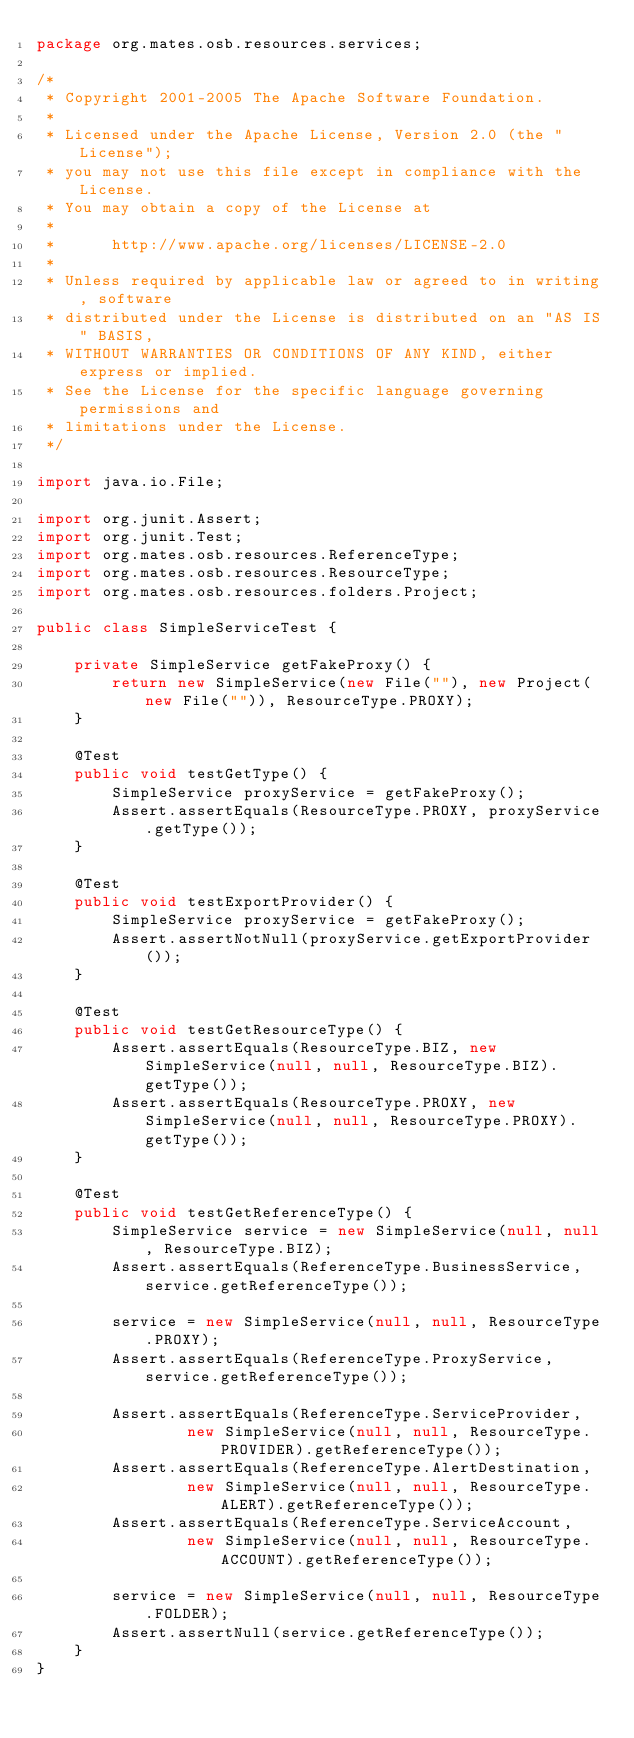Convert code to text. <code><loc_0><loc_0><loc_500><loc_500><_Java_>package org.mates.osb.resources.services;

/*
 * Copyright 2001-2005 The Apache Software Foundation.
 *
 * Licensed under the Apache License, Version 2.0 (the "License");
 * you may not use this file except in compliance with the License.
 * You may obtain a copy of the License at
 *
 *      http://www.apache.org/licenses/LICENSE-2.0
 *
 * Unless required by applicable law or agreed to in writing, software
 * distributed under the License is distributed on an "AS IS" BASIS,
 * WITHOUT WARRANTIES OR CONDITIONS OF ANY KIND, either express or implied.
 * See the License for the specific language governing permissions and
 * limitations under the License.
 */

import java.io.File;

import org.junit.Assert;
import org.junit.Test;
import org.mates.osb.resources.ReferenceType;
import org.mates.osb.resources.ResourceType;
import org.mates.osb.resources.folders.Project;

public class SimpleServiceTest {

	private SimpleService getFakeProxy() {
		return new SimpleService(new File(""), new Project(new File("")), ResourceType.PROXY);
	}

	@Test
	public void testGetType() {
		SimpleService proxyService = getFakeProxy();
		Assert.assertEquals(ResourceType.PROXY, proxyService.getType());
	}

	@Test
	public void testExportProvider() {
		SimpleService proxyService = getFakeProxy();
		Assert.assertNotNull(proxyService.getExportProvider());
	}
	
	@Test
	public void testGetResourceType() {
		Assert.assertEquals(ResourceType.BIZ, new SimpleService(null, null, ResourceType.BIZ).getType());
		Assert.assertEquals(ResourceType.PROXY, new SimpleService(null, null, ResourceType.PROXY).getType());
	}

	@Test
	public void testGetReferenceType() {
		SimpleService service = new SimpleService(null, null, ResourceType.BIZ);
		Assert.assertEquals(ReferenceType.BusinessService, service.getReferenceType());

		service = new SimpleService(null, null, ResourceType.PROXY);
		Assert.assertEquals(ReferenceType.ProxyService, service.getReferenceType());

		Assert.assertEquals(ReferenceType.ServiceProvider,
				new SimpleService(null, null, ResourceType.PROVIDER).getReferenceType());
		Assert.assertEquals(ReferenceType.AlertDestination,
				new SimpleService(null, null, ResourceType.ALERT).getReferenceType());
		Assert.assertEquals(ReferenceType.ServiceAccount,
				new SimpleService(null, null, ResourceType.ACCOUNT).getReferenceType());

		service = new SimpleService(null, null, ResourceType.FOLDER);
		Assert.assertNull(service.getReferenceType());
	}
}
</code> 